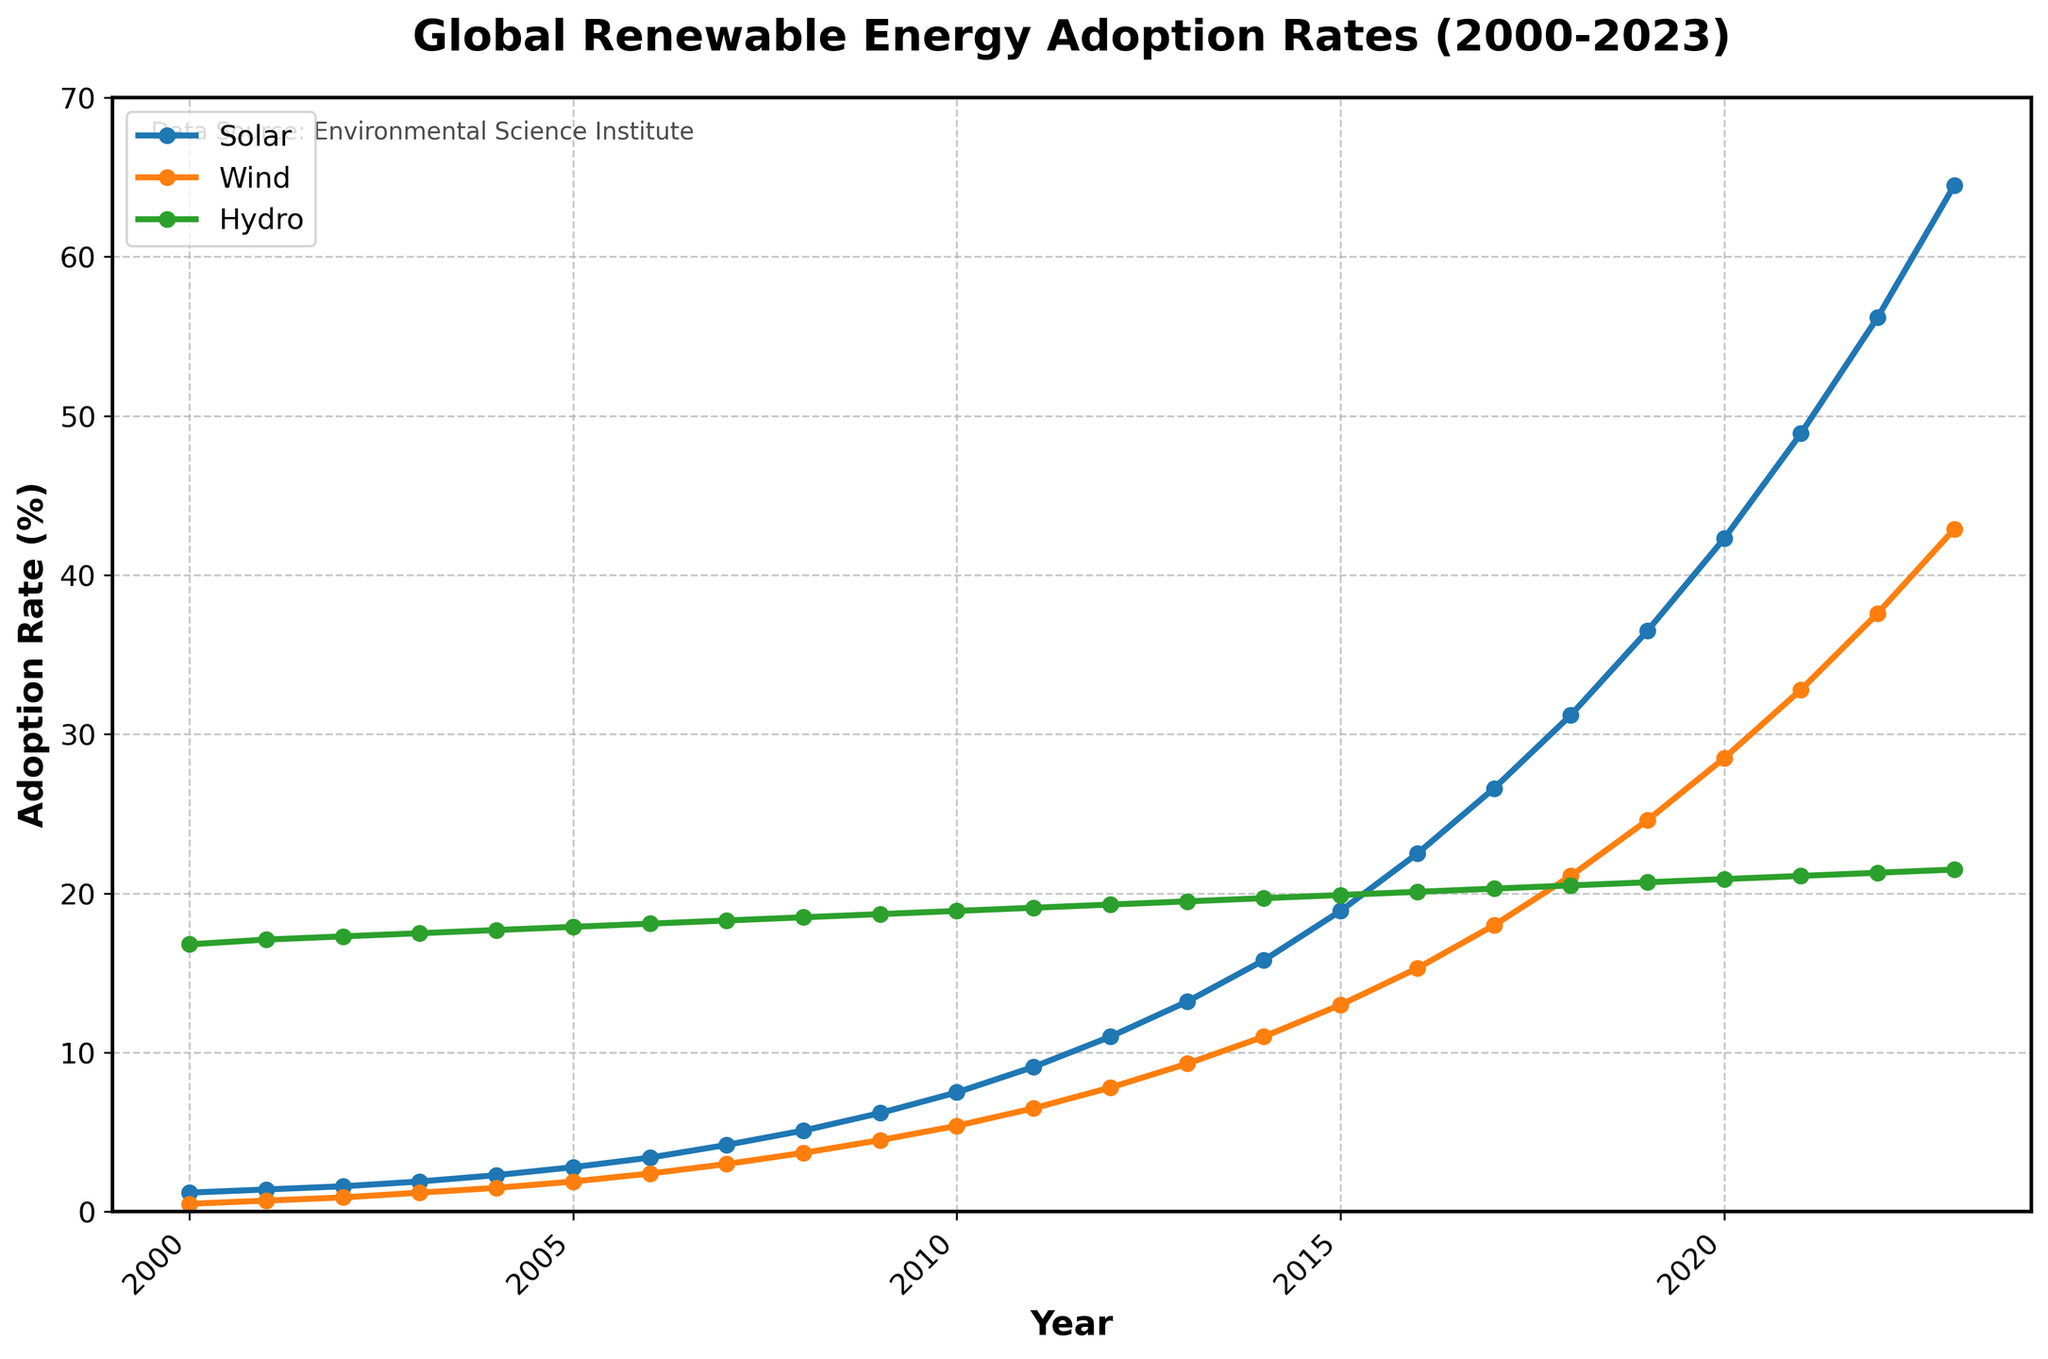What is the trend in Solar energy adoption from 2000 to 2023? To determine the trend, observe the points for Solar from 2000 to 2023. The adoption rate starts at 1.2% in 2000 and increases steadily to 64.5% in 2023. This signifies a steady upward trend.
Answer: Upward trend In what year did Wind energy adoption surpass 20%? Look at the Wind energy adoption curve and find the year where the value crosses 20%. The adoption rate is 21.1% in 2018, which is the first year it surpasses 20%.
Answer: 2018 By how much did Solar energy adoption increase from 2010 to 2020? Find the adoption rates for 2010 and 2020, which are 7.5% and 42.3%, respectively. Subtract the value for 2010 from 2020: 42.3% - 7.5% = 34.8%.
Answer: 34.8% Compare the adoption rates of Solar and Wind energy in 2023. Which one is higher, and by how much? Look at the adoption rates in 2023: Solar is at 64.5% and Wind is at 42.9%. Subtract the value for Wind from Solar: 64.5% - 42.9% = 21.6%. Solar is higher.
Answer: Solar by 21.6% What is the average adoption rate of Hydro energy from 2000 to 2023? Sum the Hydro energy adoption rates from 2000 to 2023 and divide by the number of years. Total sum = 457.9%, number of years = 24. Average = 457.9% / 24 ≈ 19.1%.
Answer: 19.1% Which renewable energy source had the highest adoption rate in 2013? Compare the adoption rates in 2013: Solar is 13.2%, Wind is 9.3%, and Hydro is 19.5%. Hydro has the highest rate.
Answer: Hydro What was the increase in Wind energy adoption from 2005 to 2015 compared to the increase in Hydro energy adoption in the same period? First, calculate the differences: Wind in 2015 (13.0%) - Wind in 2005 (1.9%) = 11.1%. Hydro in 2015 (19.9%) - Hydro in 2005 (17.9%) = 2.0%. Comparison: 11.1% (Wind) vs. 2.0% (Hydro).
Answer: Wind by 9.1% Did Solar energy adoption ever decrease between 2000 and 2023? Examine the Solar energy adoption trend line. The adoption rate consistently increases each year from 2000 to 2023 with no decreases.
Answer: No When did the adoption rate of Wind energy reach 10%? Identify the year when Wind energy adoption rate first reaches 10%. This occurs in 2014 with an adoption rate of 11.0%.
Answer: 2014 By how much did the adoption rate of Hydro energy increase from 2000 to 2023? Find the Hydro adoption rates in 2000 and 2023, which are 16.8% and 21.5%, respectively. Subtract the 2000 value from the 2023 value: 21.5% - 16.8% = 4.7%.
Answer: 4.7% 